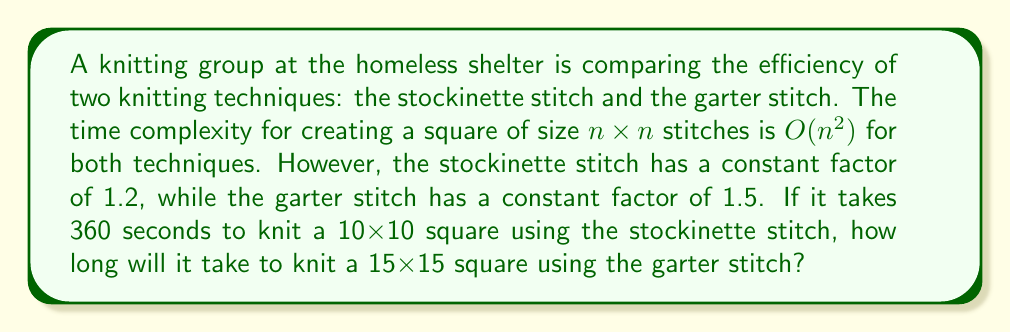Can you solve this math problem? Let's approach this step-by-step:

1) First, we need to understand the time complexity. Both techniques have $O(n^2)$ complexity, but with different constant factors:
   - Stockinette: $T_s(n) = 1.2n^2$
   - Garter: $T_g(n) = 1.5n^2$

2) We're given that for a 10x10 square using stockinette stitch, it takes 360 seconds. Let's use this to find the actual time function for stockinette:

   $360 = 1.2 \cdot 10^2$
   $360 = 1.2 \cdot 100$
   $360 = 120$

   This means our time unit is 3 seconds. So the actual time functions are:
   - Stockinette: $T_s(n) = 3.6n^2$ seconds
   - Garter: $T_g(n) = 4.5n^2$ seconds

3) Now, we need to calculate $T_g(15)$:

   $T_g(15) = 4.5 \cdot 15^2$
   $= 4.5 \cdot 225$
   $= 1012.5$ seconds

Therefore, it will take 1012.5 seconds to knit a 15x15 square using the garter stitch.
Answer: 1012.5 seconds 